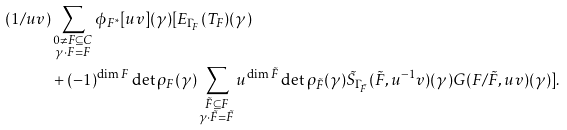Convert formula to latex. <formula><loc_0><loc_0><loc_500><loc_500>( 1 / u v ) & \sum _ { \substack { 0 \ne F \subseteq C \\ \gamma \cdot F = F } } \phi _ { F ^ { * } } [ u v ] ( \gamma ) [ E _ { \Gamma _ { F } } ( T _ { F } ) ( \gamma ) \\ & + ( - 1 ) ^ { \dim F } \det \rho _ { F } ( \gamma ) \sum _ { \substack { \tilde { F } \subseteq F \\ \gamma \cdot \tilde { F } = \tilde { F } } } u ^ { \dim \tilde { F } } \det \rho _ { \tilde { F } } ( \gamma ) \tilde { S } _ { \Gamma _ { \tilde { F } } } ( \tilde { F } , u ^ { - 1 } v ) ( \gamma ) G ( F / \tilde { F } , u v ) ( \gamma ) ] .</formula> 